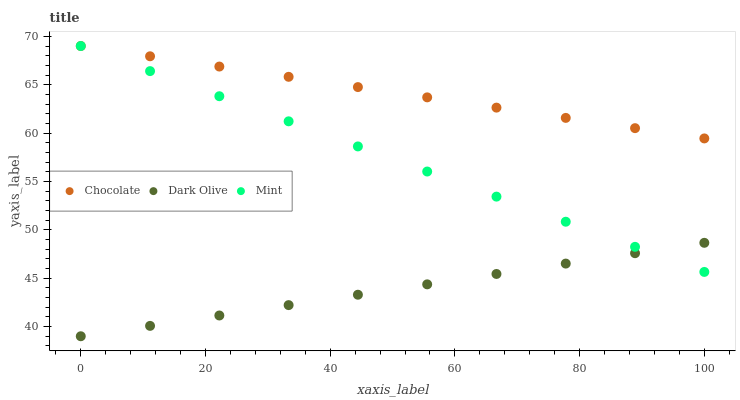Does Dark Olive have the minimum area under the curve?
Answer yes or no. Yes. Does Chocolate have the maximum area under the curve?
Answer yes or no. Yes. Does Mint have the minimum area under the curve?
Answer yes or no. No. Does Mint have the maximum area under the curve?
Answer yes or no. No. Is Dark Olive the smoothest?
Answer yes or no. Yes. Is Mint the roughest?
Answer yes or no. Yes. Is Chocolate the smoothest?
Answer yes or no. No. Is Chocolate the roughest?
Answer yes or no. No. Does Dark Olive have the lowest value?
Answer yes or no. Yes. Does Mint have the lowest value?
Answer yes or no. No. Does Chocolate have the highest value?
Answer yes or no. Yes. Is Dark Olive less than Chocolate?
Answer yes or no. Yes. Is Chocolate greater than Dark Olive?
Answer yes or no. Yes. Does Dark Olive intersect Mint?
Answer yes or no. Yes. Is Dark Olive less than Mint?
Answer yes or no. No. Is Dark Olive greater than Mint?
Answer yes or no. No. Does Dark Olive intersect Chocolate?
Answer yes or no. No. 